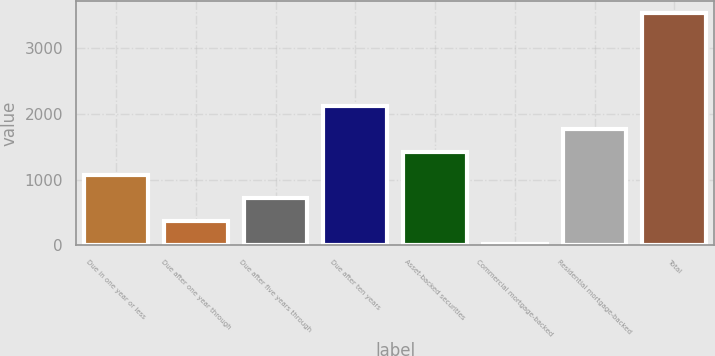Convert chart. <chart><loc_0><loc_0><loc_500><loc_500><bar_chart><fcel>Due in one year or less<fcel>Due after one year through<fcel>Due after five years through<fcel>Due after ten years<fcel>Asset-backed securities<fcel>Commercial mortgage-backed<fcel>Residential mortgage-backed<fcel>Total<nl><fcel>1069.2<fcel>362.4<fcel>715.8<fcel>2129.4<fcel>1422.6<fcel>9<fcel>1776<fcel>3543<nl></chart> 